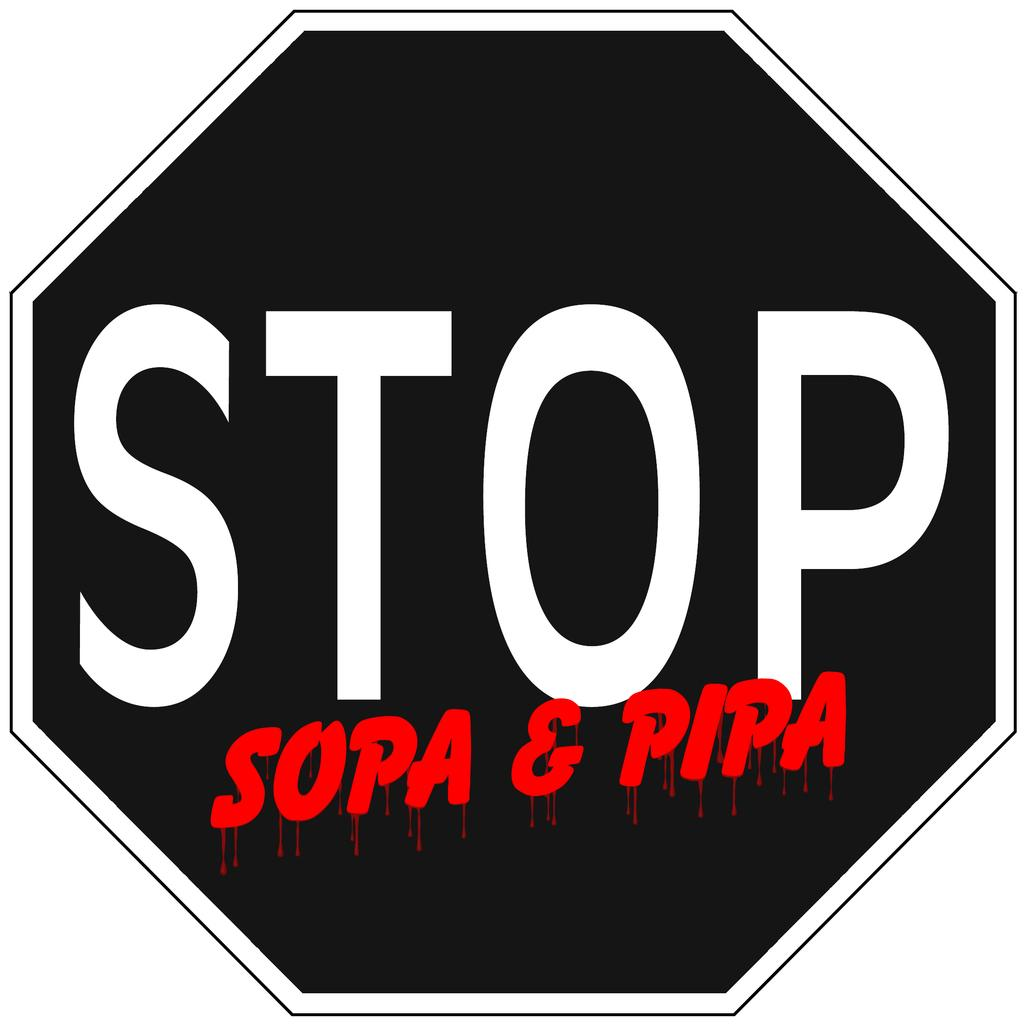<image>
Summarize the visual content of the image. a stop sign that is black and red in color 